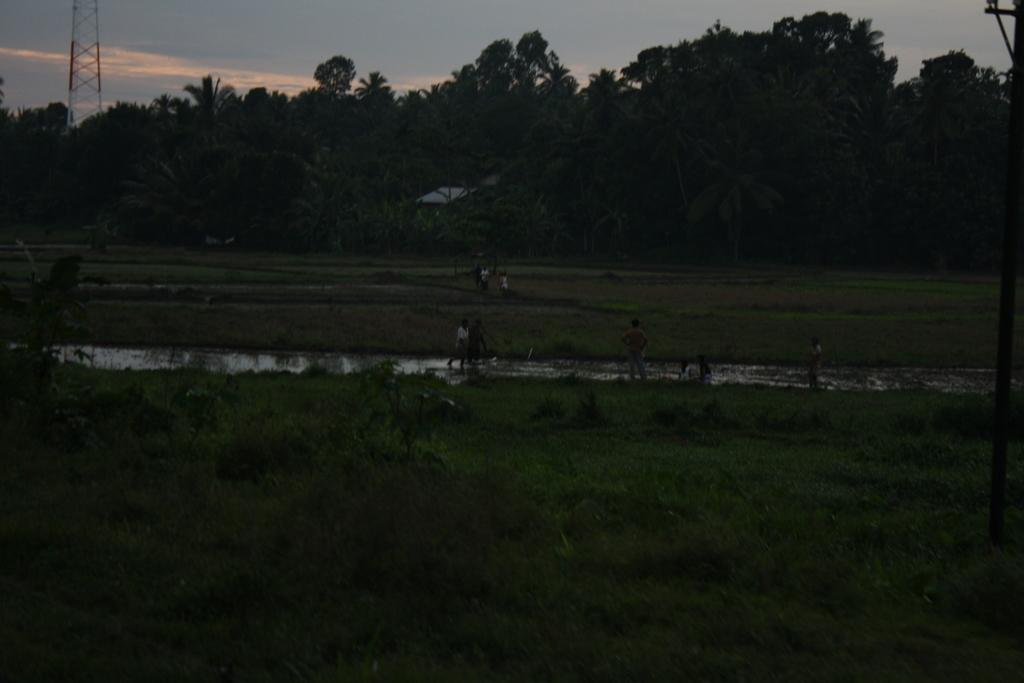What are the people in the image doing? The people in the image are standing near the water. What can be seen in the background of the image? There are many trees visible in the background, as well as a pole and the sky. What type of cream is being used to paint the cork in the image? There is no cream or cork present in the image; it features people standing near the water with trees, a pole, and the sky visible in the background. 